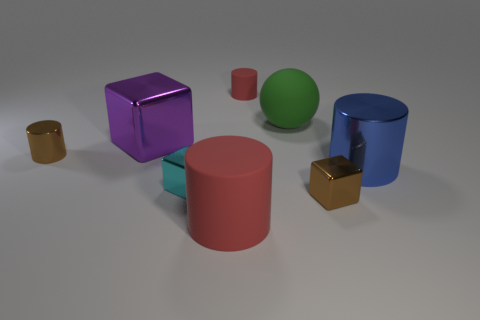Can you tell me which objects have a similar shape? The two cylinders on the left, one small and gold colored and the other larger and pink, have similar shapes. Additionally, the two cubes to the right, one large and purple and the other smaller and deep gold, are also shaped alike. 